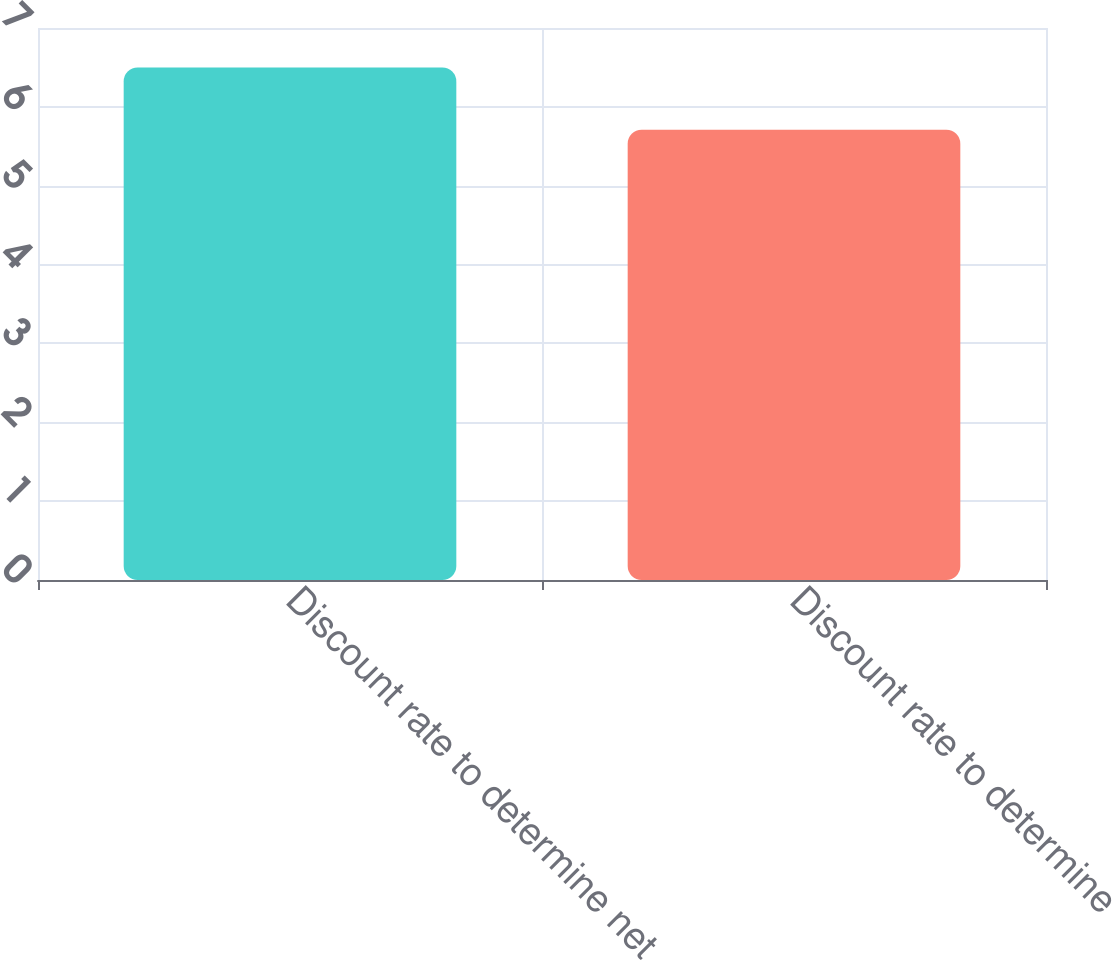Convert chart to OTSL. <chart><loc_0><loc_0><loc_500><loc_500><bar_chart><fcel>Discount rate to determine net<fcel>Discount rate to determine<nl><fcel>6.5<fcel>5.71<nl></chart> 